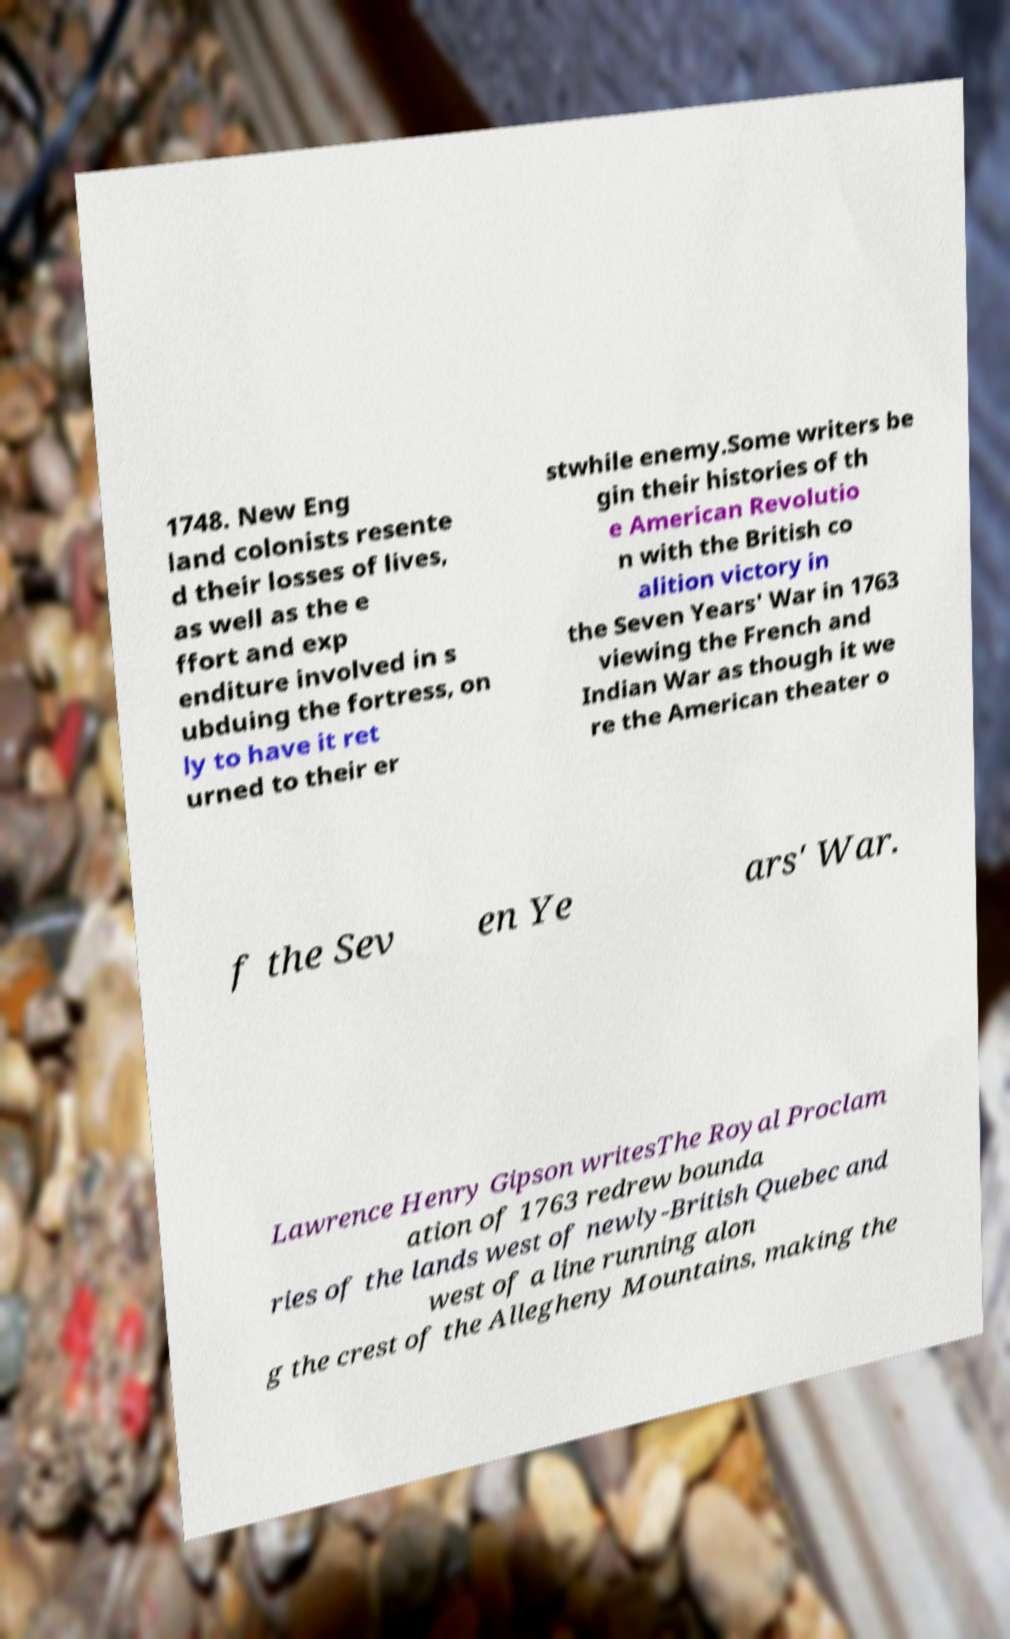Can you read and provide the text displayed in the image?This photo seems to have some interesting text. Can you extract and type it out for me? 1748. New Eng land colonists resente d their losses of lives, as well as the e ffort and exp enditure involved in s ubduing the fortress, on ly to have it ret urned to their er stwhile enemy.Some writers be gin their histories of th e American Revolutio n with the British co alition victory in the Seven Years' War in 1763 viewing the French and Indian War as though it we re the American theater o f the Sev en Ye ars' War. Lawrence Henry Gipson writesThe Royal Proclam ation of 1763 redrew bounda ries of the lands west of newly-British Quebec and west of a line running alon g the crest of the Allegheny Mountains, making the 